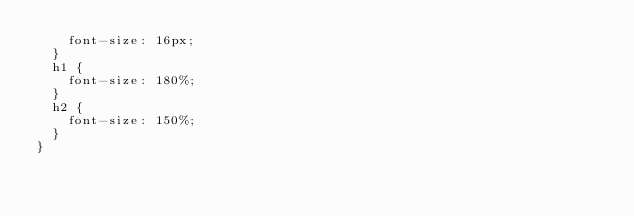<code> <loc_0><loc_0><loc_500><loc_500><_CSS_>    font-size: 16px;
  }
  h1 {
    font-size: 180%;
  }
  h2 {
    font-size: 150%;
  }
}
</code> 